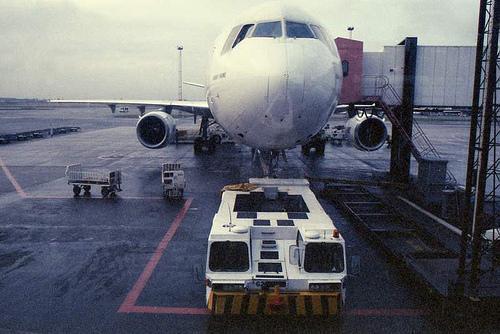How many planes are there?
Give a very brief answer. 1. 